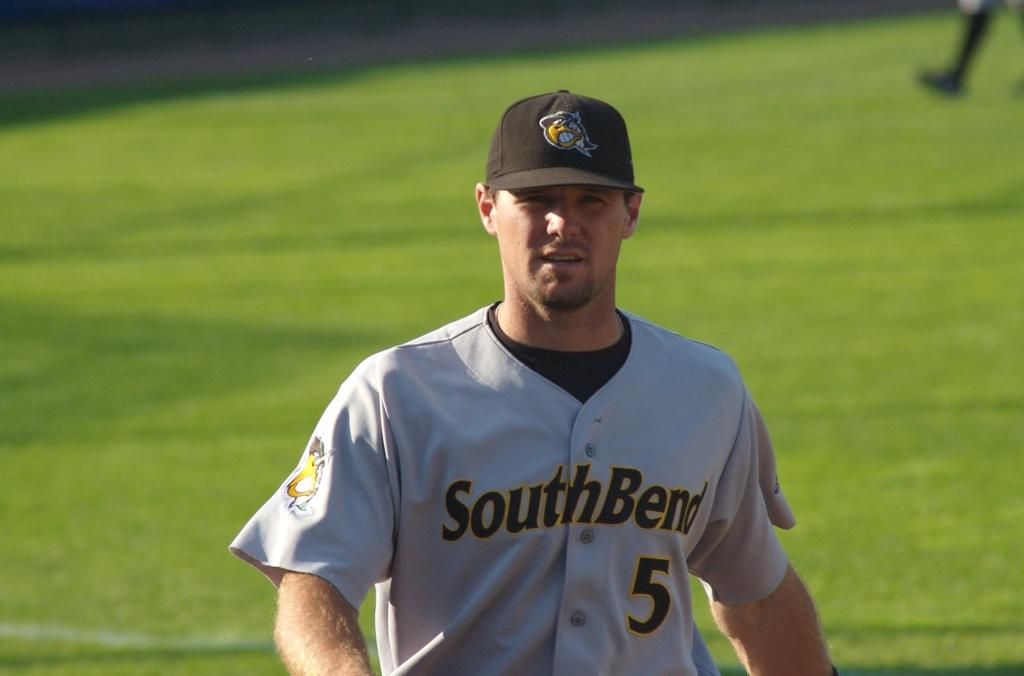<image>
Create a compact narrative representing the image presented. Player number 5 wearing a South Bend jersey stands on a baseball field. 